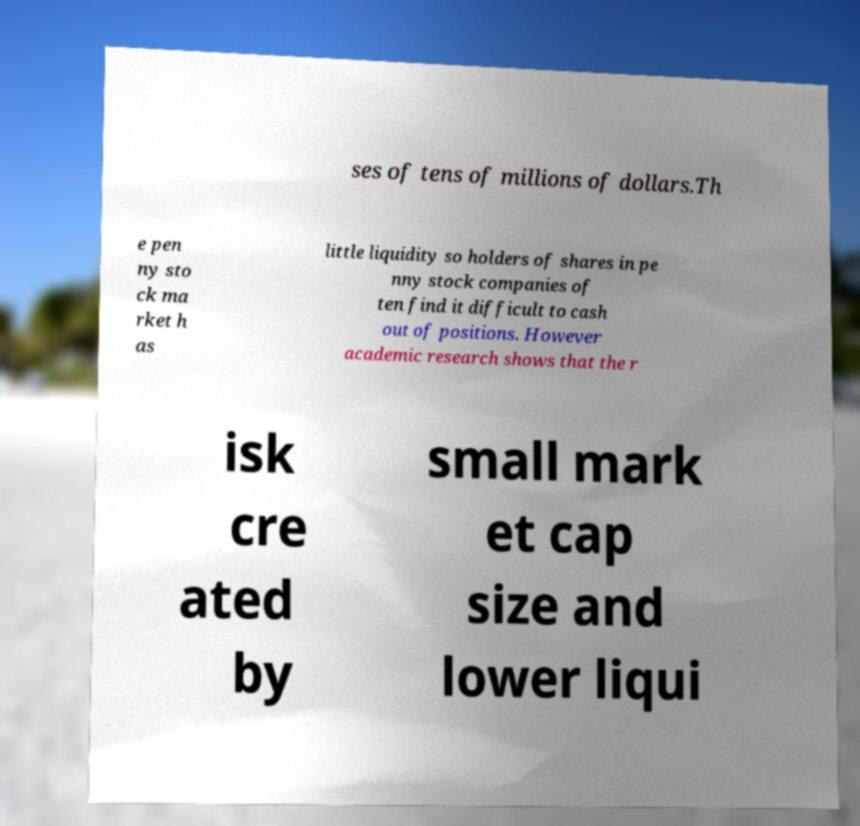Please identify and transcribe the text found in this image. ses of tens of millions of dollars.Th e pen ny sto ck ma rket h as little liquidity so holders of shares in pe nny stock companies of ten find it difficult to cash out of positions. However academic research shows that the r isk cre ated by small mark et cap size and lower liqui 